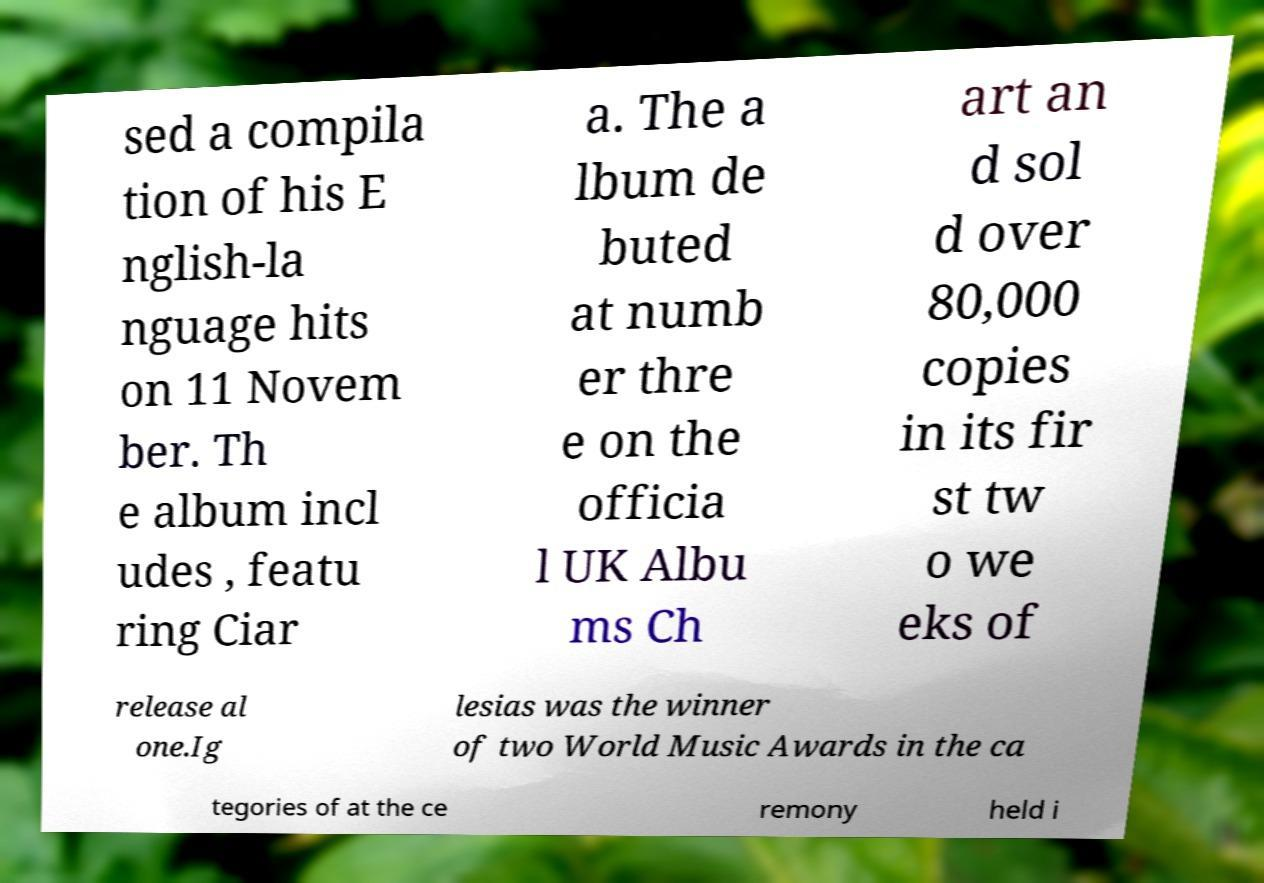What messages or text are displayed in this image? I need them in a readable, typed format. sed a compila tion of his E nglish-la nguage hits on 11 Novem ber. Th e album incl udes , featu ring Ciar a. The a lbum de buted at numb er thre e on the officia l UK Albu ms Ch art an d sol d over 80,000 copies in its fir st tw o we eks of release al one.Ig lesias was the winner of two World Music Awards in the ca tegories of at the ce remony held i 